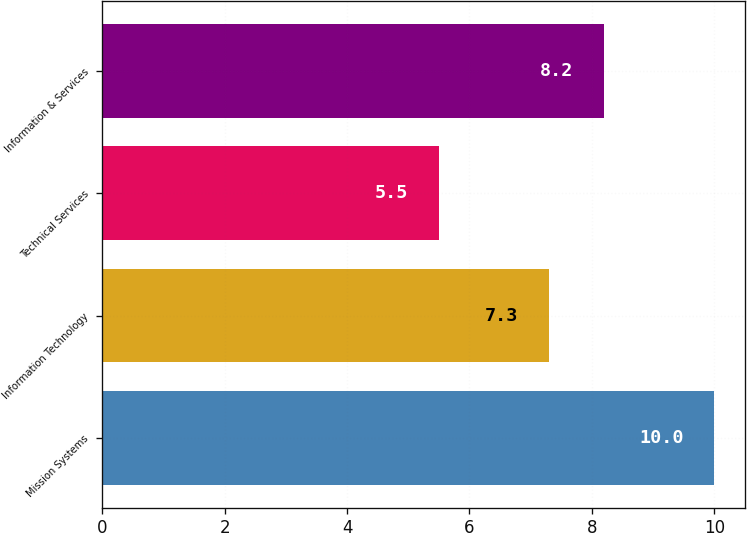Convert chart. <chart><loc_0><loc_0><loc_500><loc_500><bar_chart><fcel>Mission Systems<fcel>Information Technology<fcel>Technical Services<fcel>Information & Services<nl><fcel>10<fcel>7.3<fcel>5.5<fcel>8.2<nl></chart> 